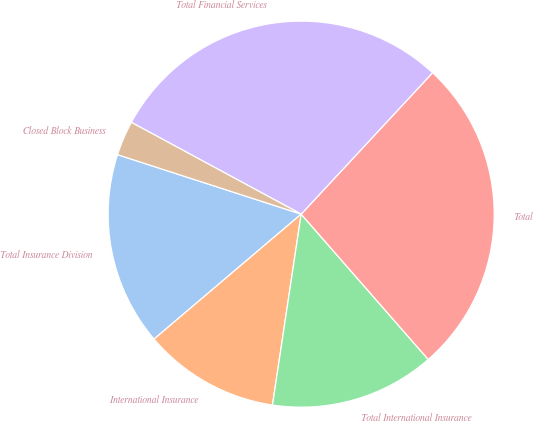Convert chart. <chart><loc_0><loc_0><loc_500><loc_500><pie_chart><fcel>Total Insurance Division<fcel>International Insurance<fcel>Total International Insurance<fcel>Total<fcel>Total Financial Services<fcel>Closed Block Business<nl><fcel>16.19%<fcel>11.42%<fcel>13.81%<fcel>26.65%<fcel>29.03%<fcel>2.9%<nl></chart> 